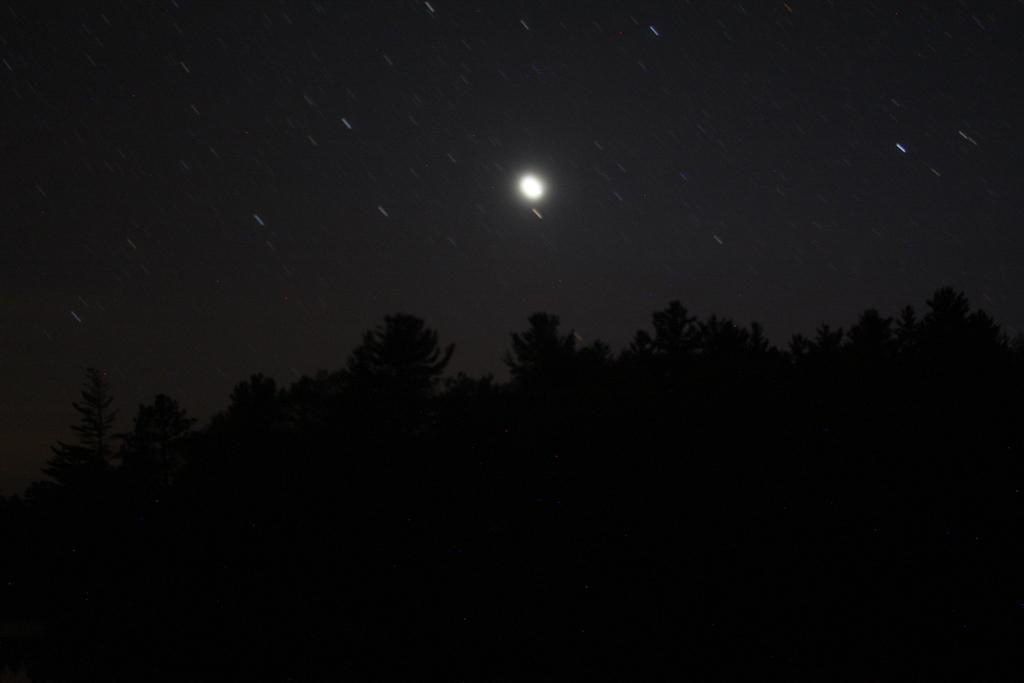Can you describe this image briefly? In the image there are many trees and in the background there is a sky. 